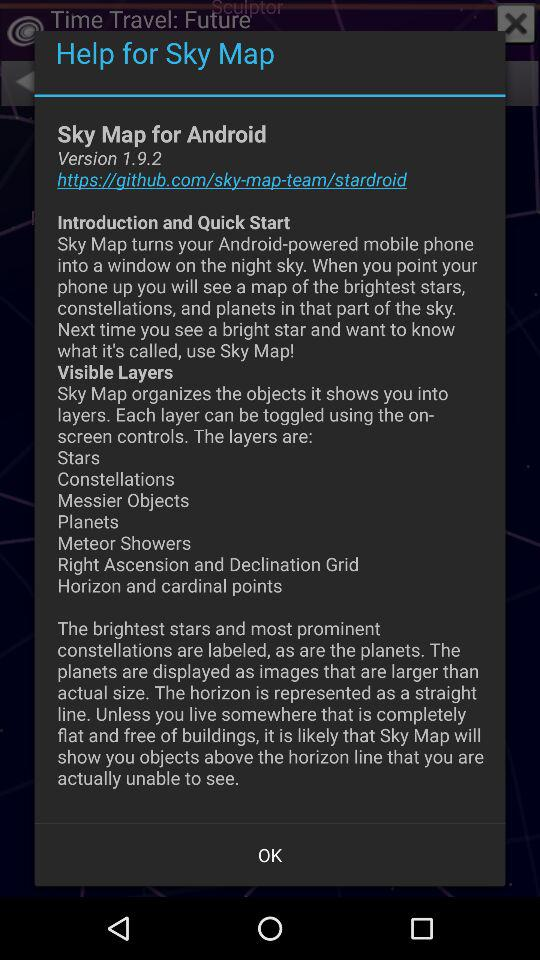What is the version? The version is 1.9.2. 